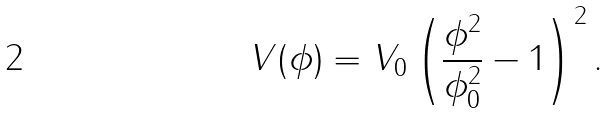<formula> <loc_0><loc_0><loc_500><loc_500>V ( \phi ) = V _ { 0 } \left ( \frac { \phi ^ { 2 } } { \phi _ { 0 } ^ { 2 } } - 1 \right ) ^ { 2 } .</formula> 